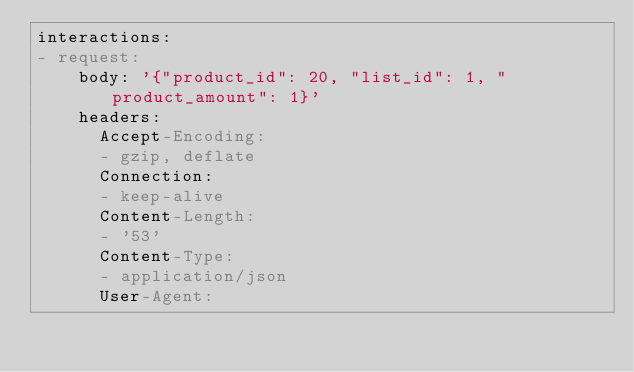<code> <loc_0><loc_0><loc_500><loc_500><_YAML_>interactions:
- request:
    body: '{"product_id": 20, "list_id": 1, "product_amount": 1}'
    headers:
      Accept-Encoding:
      - gzip, deflate
      Connection:
      - keep-alive
      Content-Length:
      - '53'
      Content-Type:
      - application/json
      User-Agent:</code> 